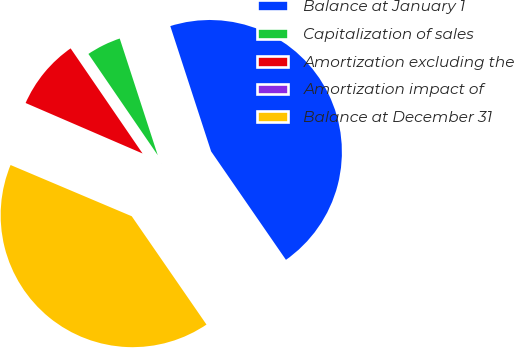Convert chart. <chart><loc_0><loc_0><loc_500><loc_500><pie_chart><fcel>Balance at January 1<fcel>Capitalization of sales<fcel>Amortization excluding the<fcel>Amortization impact of<fcel>Balance at December 31<nl><fcel>45.4%<fcel>4.54%<fcel>8.96%<fcel>0.12%<fcel>40.98%<nl></chart> 